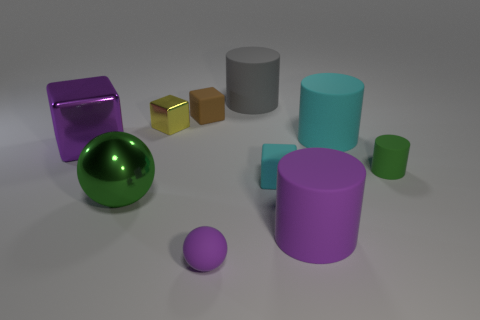What is the big object that is left of the large gray cylinder and behind the big metallic ball made of?
Ensure brevity in your answer.  Metal. What shape is the large purple object that is made of the same material as the small green cylinder?
Make the answer very short. Cylinder. There is a cyan cylinder that is the same material as the small green object; what size is it?
Give a very brief answer. Large. What is the shape of the tiny rubber object that is behind the green metal object and in front of the small green rubber cylinder?
Provide a succinct answer. Cube. There is a rubber block that is on the left side of the cylinder that is behind the tiny brown block; what size is it?
Offer a terse response. Small. What number of other objects are there of the same color as the tiny metallic block?
Your answer should be very brief. 0. What is the material of the yellow object?
Your response must be concise. Metal. Are there any small purple balls?
Provide a succinct answer. Yes. Is the number of small yellow metallic blocks that are to the left of the big purple block the same as the number of rubber balls?
Provide a short and direct response. No. Is there any other thing that is the same material as the purple cylinder?
Offer a very short reply. Yes. 